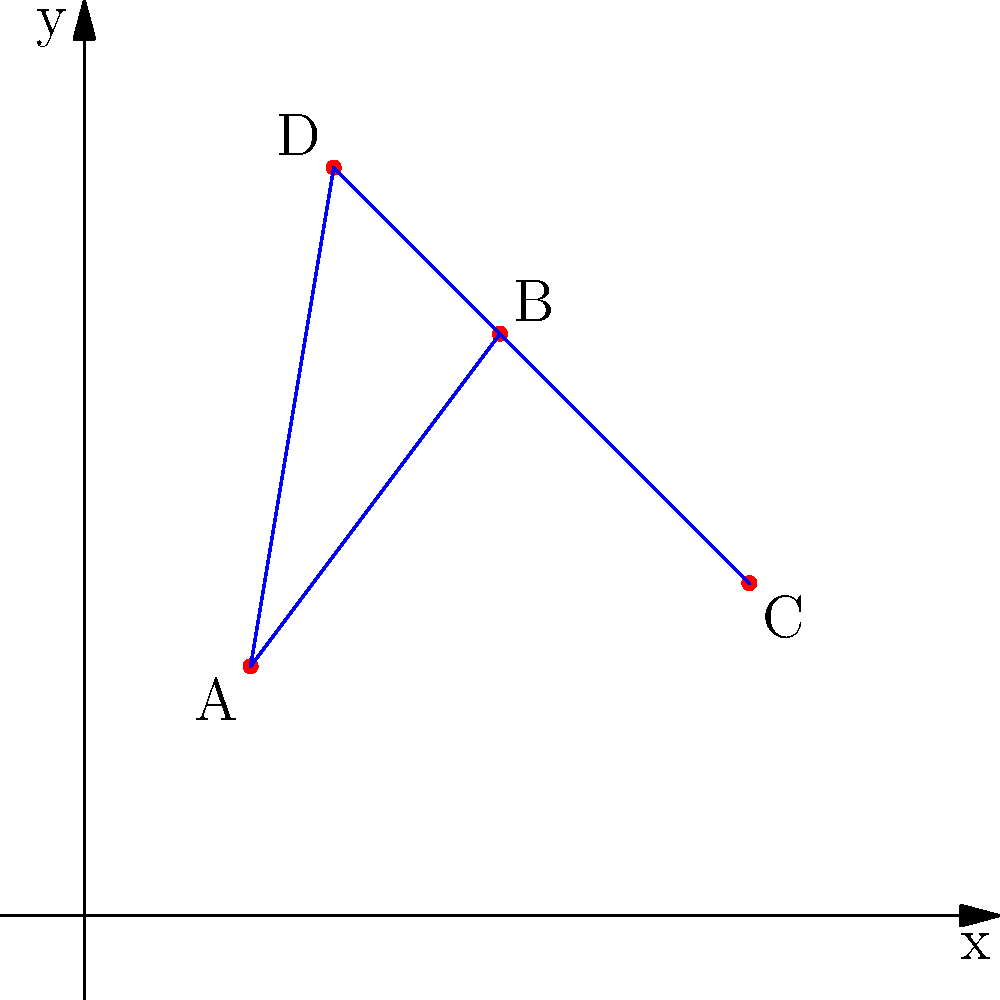In your mystery novel, you've plotted four key crime scenes (A, B, C, and D) on a coordinate grid to visualize their spatial relationships. The coordinates of these scenes are A(2,3), B(5,7), C(8,4), and D(3,9). If you connect these points to form a quadrilateral, what is the area of this shape? Round your answer to the nearest whole number. To find the area of the quadrilateral formed by the crime scenes, we can use the Shoelace formula (also known as the surveyor's formula). This method is particularly useful for calculating the area of an irregular polygon given the coordinates of its vertices.

The steps are as follows:

1) First, let's arrange the coordinates in order:
   A(2,3), B(5,7), C(8,4), D(3,9)

2) The Shoelace formula for a quadrilateral ABCD is:
   Area = $\frac{1}{2}|x_1y_2 + x_2y_3 + x_3y_4 + x_4y_1 - (y_1x_2 + y_2x_3 + y_3x_4 + y_4x_1)|$

3) Substituting our coordinates:
   Area = $\frac{1}{2}|(2 \cdot 7 + 5 \cdot 4 + 8 \cdot 9 + 3 \cdot 3) - (3 \cdot 5 + 7 \cdot 8 + 4 \cdot 3 + 9 \cdot 2)|$

4) Simplifying:
   Area = $\frac{1}{2}|(14 + 20 + 72 + 9) - (15 + 56 + 12 + 18)|$
   Area = $\frac{1}{2}|115 - 101|$
   Area = $\frac{1}{2} \cdot 14$
   Area = 7

5) The question asks to round to the nearest whole number, but our result is already a whole number.

Therefore, the area of the quadrilateral formed by the four crime scenes is 7 square units.
Answer: 7 square units 